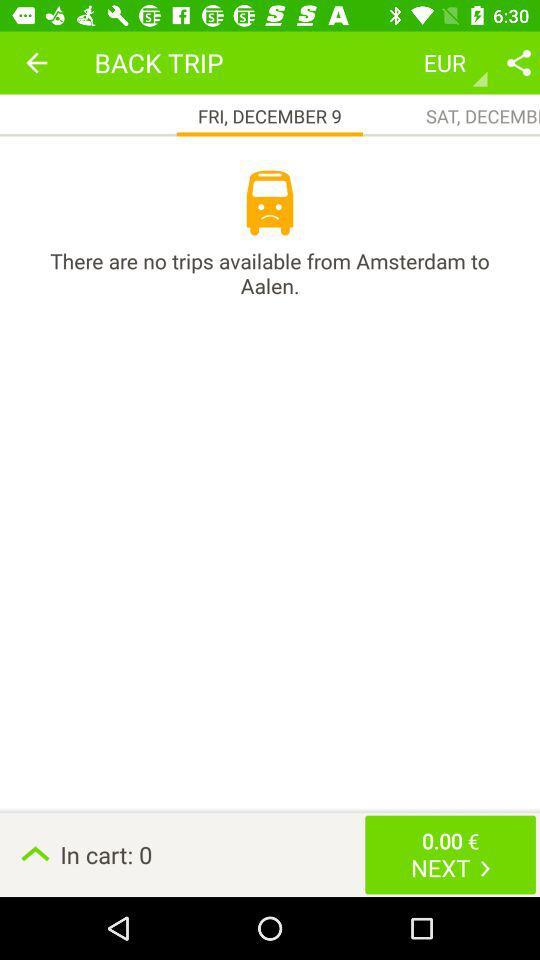How many items are in the cart? There are 0 items in the cart. 